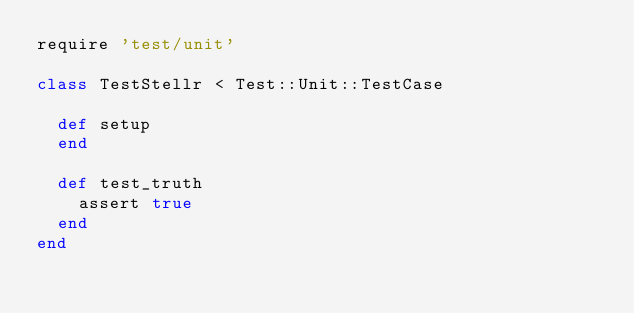<code> <loc_0><loc_0><loc_500><loc_500><_Ruby_>require 'test/unit'

class TestStellr < Test::Unit::TestCase
  
  def setup
  end
  
  def test_truth
    assert true
  end
end
</code> 